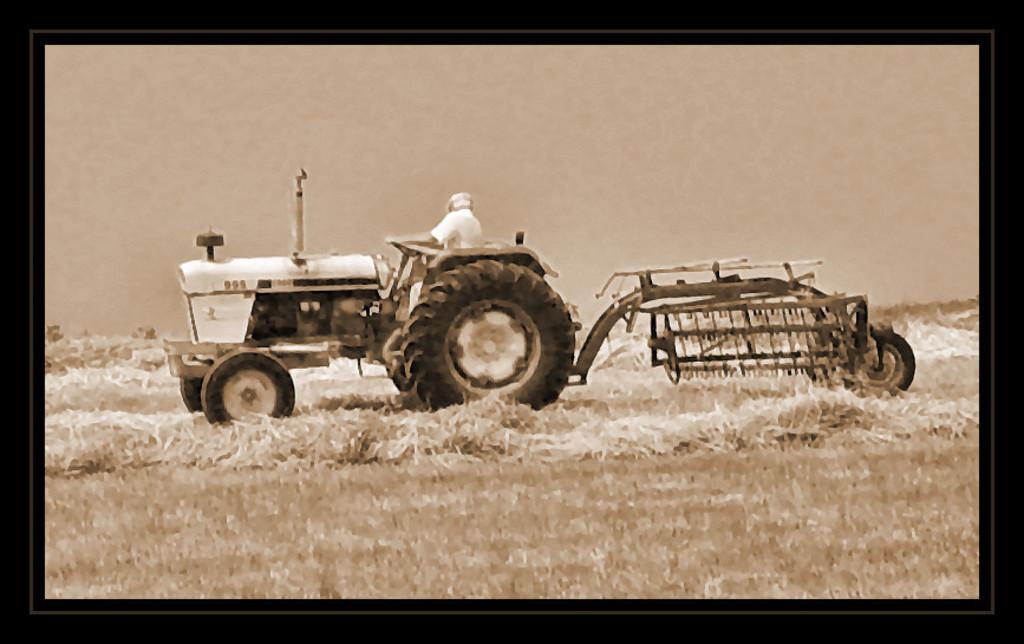Describe this image in one or two sentences. In this image we can see a photo frame. In the photo frame we can see the picture of a man sitting on the tractor and ploughing the land. 